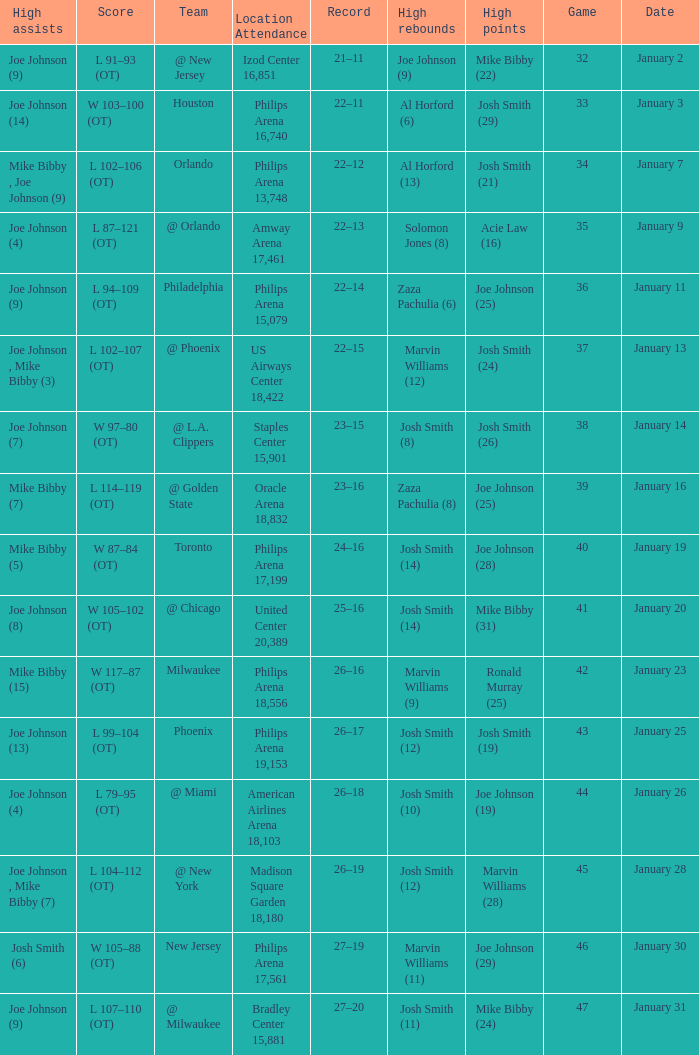Would you be able to parse every entry in this table? {'header': ['High assists', 'Score', 'Team', 'Location Attendance', 'Record', 'High rebounds', 'High points', 'Game', 'Date'], 'rows': [['Joe Johnson (9)', 'L 91–93 (OT)', '@ New Jersey', 'Izod Center 16,851', '21–11', 'Joe Johnson (9)', 'Mike Bibby (22)', '32', 'January 2'], ['Joe Johnson (14)', 'W 103–100 (OT)', 'Houston', 'Philips Arena 16,740', '22–11', 'Al Horford (6)', 'Josh Smith (29)', '33', 'January 3'], ['Mike Bibby , Joe Johnson (9)', 'L 102–106 (OT)', 'Orlando', 'Philips Arena 13,748', '22–12', 'Al Horford (13)', 'Josh Smith (21)', '34', 'January 7'], ['Joe Johnson (4)', 'L 87–121 (OT)', '@ Orlando', 'Amway Arena 17,461', '22–13', 'Solomon Jones (8)', 'Acie Law (16)', '35', 'January 9'], ['Joe Johnson (9)', 'L 94–109 (OT)', 'Philadelphia', 'Philips Arena 15,079', '22–14', 'Zaza Pachulia (6)', 'Joe Johnson (25)', '36', 'January 11'], ['Joe Johnson , Mike Bibby (3)', 'L 102–107 (OT)', '@ Phoenix', 'US Airways Center 18,422', '22–15', 'Marvin Williams (12)', 'Josh Smith (24)', '37', 'January 13'], ['Joe Johnson (7)', 'W 97–80 (OT)', '@ L.A. Clippers', 'Staples Center 15,901', '23–15', 'Josh Smith (8)', 'Josh Smith (26)', '38', 'January 14'], ['Mike Bibby (7)', 'L 114–119 (OT)', '@ Golden State', 'Oracle Arena 18,832', '23–16', 'Zaza Pachulia (8)', 'Joe Johnson (25)', '39', 'January 16'], ['Mike Bibby (5)', 'W 87–84 (OT)', 'Toronto', 'Philips Arena 17,199', '24–16', 'Josh Smith (14)', 'Joe Johnson (28)', '40', 'January 19'], ['Joe Johnson (8)', 'W 105–102 (OT)', '@ Chicago', 'United Center 20,389', '25–16', 'Josh Smith (14)', 'Mike Bibby (31)', '41', 'January 20'], ['Mike Bibby (15)', 'W 117–87 (OT)', 'Milwaukee', 'Philips Arena 18,556', '26–16', 'Marvin Williams (9)', 'Ronald Murray (25)', '42', 'January 23'], ['Joe Johnson (13)', 'L 99–104 (OT)', 'Phoenix', 'Philips Arena 19,153', '26–17', 'Josh Smith (12)', 'Josh Smith (19)', '43', 'January 25'], ['Joe Johnson (4)', 'L 79–95 (OT)', '@ Miami', 'American Airlines Arena 18,103', '26–18', 'Josh Smith (10)', 'Joe Johnson (19)', '44', 'January 26'], ['Joe Johnson , Mike Bibby (7)', 'L 104–112 (OT)', '@ New York', 'Madison Square Garden 18,180', '26–19', 'Josh Smith (12)', 'Marvin Williams (28)', '45', 'January 28'], ['Josh Smith (6)', 'W 105–88 (OT)', 'New Jersey', 'Philips Arena 17,561', '27–19', 'Marvin Williams (11)', 'Joe Johnson (29)', '46', 'January 30'], ['Joe Johnson (9)', 'L 107–110 (OT)', '@ Milwaukee', 'Bradley Center 15,881', '27–20', 'Josh Smith (11)', 'Mike Bibby (24)', '47', 'January 31']]} Which date was game 35 on? January 9. 